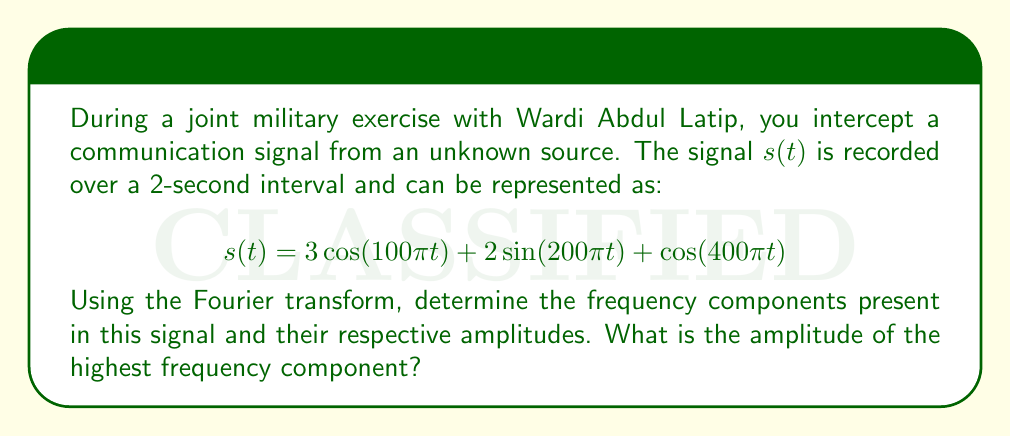Can you answer this question? To analyze the frequency components of the signal, we need to identify the frequencies present in each term of the given function and calculate their amplitudes.

1) First, let's identify the frequencies:
   - $3\cos(100\pi t)$: frequency $f_1 = 100\pi/(2\pi) = 50$ Hz
   - $2\sin(200\pi t)$: frequency $f_2 = 200\pi/(2\pi) = 100$ Hz
   - $\cos(400\pi t)$: frequency $f_3 = 400\pi/(2\pi) = 200$ Hz

2) Now, let's calculate the amplitudes:
   - For $3\cos(100\pi t)$: amplitude $A_1 = 3$
   - For $2\sin(200\pi t)$: amplitude $A_2 = 2$
   - For $\cos(400\pi t)$: amplitude $A_3 = 1$

3) The Fourier transform of this signal would have peaks at these three frequencies with the corresponding amplitudes.

4) The highest frequency component is at 200 Hz with an amplitude of 1.

This analysis reveals that the intercepted signal consists of three distinct frequency components, which could represent different channels or types of information in the military communication.
Answer: The highest frequency component is 200 Hz with an amplitude of 1. 